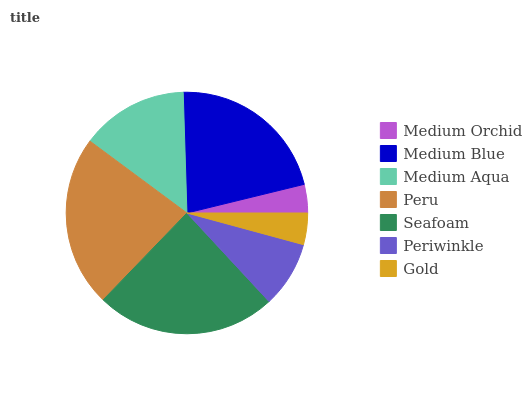Is Medium Orchid the minimum?
Answer yes or no. Yes. Is Seafoam the maximum?
Answer yes or no. Yes. Is Medium Blue the minimum?
Answer yes or no. No. Is Medium Blue the maximum?
Answer yes or no. No. Is Medium Blue greater than Medium Orchid?
Answer yes or no. Yes. Is Medium Orchid less than Medium Blue?
Answer yes or no. Yes. Is Medium Orchid greater than Medium Blue?
Answer yes or no. No. Is Medium Blue less than Medium Orchid?
Answer yes or no. No. Is Medium Aqua the high median?
Answer yes or no. Yes. Is Medium Aqua the low median?
Answer yes or no. Yes. Is Peru the high median?
Answer yes or no. No. Is Seafoam the low median?
Answer yes or no. No. 